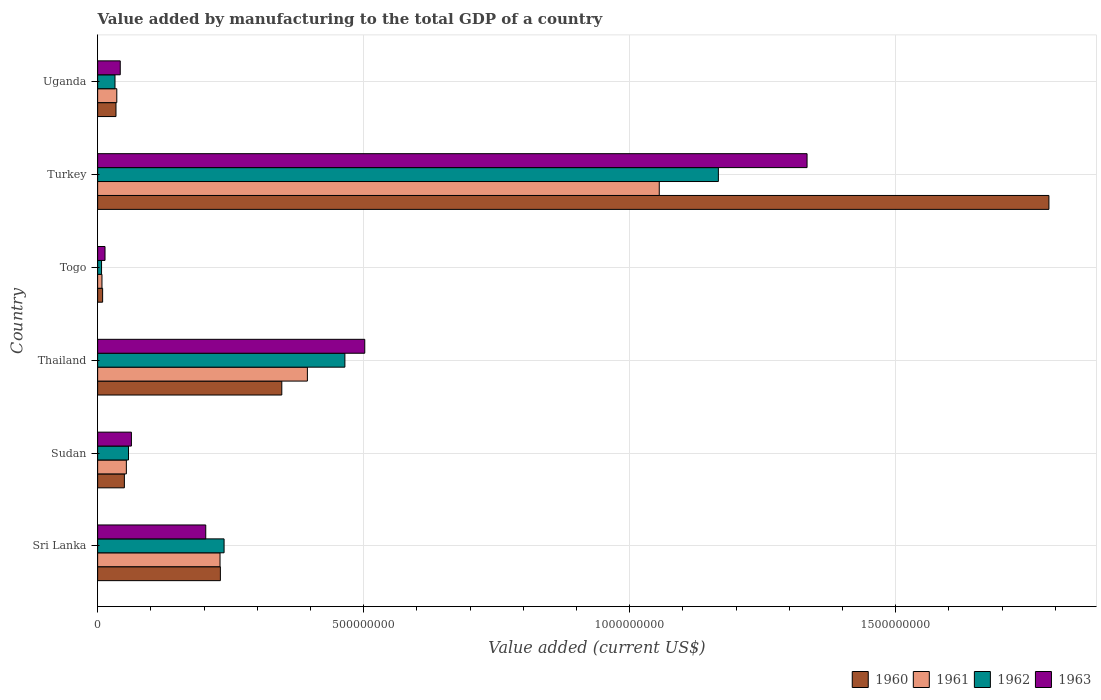How many groups of bars are there?
Provide a short and direct response. 6. Are the number of bars per tick equal to the number of legend labels?
Make the answer very short. Yes. What is the label of the 6th group of bars from the top?
Your answer should be compact. Sri Lanka. In how many cases, is the number of bars for a given country not equal to the number of legend labels?
Provide a succinct answer. 0. What is the value added by manufacturing to the total GDP in 1962 in Thailand?
Your answer should be very brief. 4.65e+08. Across all countries, what is the maximum value added by manufacturing to the total GDP in 1961?
Your answer should be compact. 1.06e+09. Across all countries, what is the minimum value added by manufacturing to the total GDP in 1962?
Provide a short and direct response. 7.35e+06. In which country was the value added by manufacturing to the total GDP in 1960 maximum?
Offer a terse response. Turkey. In which country was the value added by manufacturing to the total GDP in 1961 minimum?
Offer a terse response. Togo. What is the total value added by manufacturing to the total GDP in 1963 in the graph?
Give a very brief answer. 2.16e+09. What is the difference between the value added by manufacturing to the total GDP in 1960 in Sudan and that in Togo?
Make the answer very short. 4.09e+07. What is the difference between the value added by manufacturing to the total GDP in 1962 in Turkey and the value added by manufacturing to the total GDP in 1961 in Sri Lanka?
Give a very brief answer. 9.37e+08. What is the average value added by manufacturing to the total GDP in 1962 per country?
Your response must be concise. 3.28e+08. What is the difference between the value added by manufacturing to the total GDP in 1960 and value added by manufacturing to the total GDP in 1961 in Turkey?
Provide a succinct answer. 7.32e+08. What is the ratio of the value added by manufacturing to the total GDP in 1962 in Sri Lanka to that in Thailand?
Make the answer very short. 0.51. Is the difference between the value added by manufacturing to the total GDP in 1960 in Sri Lanka and Thailand greater than the difference between the value added by manufacturing to the total GDP in 1961 in Sri Lanka and Thailand?
Offer a terse response. Yes. What is the difference between the highest and the second highest value added by manufacturing to the total GDP in 1961?
Your answer should be compact. 6.61e+08. What is the difference between the highest and the lowest value added by manufacturing to the total GDP in 1963?
Your response must be concise. 1.32e+09. Is it the case that in every country, the sum of the value added by manufacturing to the total GDP in 1962 and value added by manufacturing to the total GDP in 1960 is greater than the sum of value added by manufacturing to the total GDP in 1963 and value added by manufacturing to the total GDP in 1961?
Make the answer very short. No. What does the 3rd bar from the top in Thailand represents?
Offer a terse response. 1961. What does the 2nd bar from the bottom in Sudan represents?
Your answer should be very brief. 1961. How many bars are there?
Your response must be concise. 24. What is the difference between two consecutive major ticks on the X-axis?
Provide a succinct answer. 5.00e+08. Does the graph contain any zero values?
Keep it short and to the point. No. Does the graph contain grids?
Keep it short and to the point. Yes. How are the legend labels stacked?
Ensure brevity in your answer.  Horizontal. What is the title of the graph?
Give a very brief answer. Value added by manufacturing to the total GDP of a country. Does "1995" appear as one of the legend labels in the graph?
Make the answer very short. No. What is the label or title of the X-axis?
Give a very brief answer. Value added (current US$). What is the Value added (current US$) in 1960 in Sri Lanka?
Keep it short and to the point. 2.31e+08. What is the Value added (current US$) of 1961 in Sri Lanka?
Keep it short and to the point. 2.30e+08. What is the Value added (current US$) in 1962 in Sri Lanka?
Provide a succinct answer. 2.38e+08. What is the Value added (current US$) in 1963 in Sri Lanka?
Give a very brief answer. 2.03e+08. What is the Value added (current US$) of 1960 in Sudan?
Keep it short and to the point. 5.03e+07. What is the Value added (current US$) in 1961 in Sudan?
Make the answer very short. 5.40e+07. What is the Value added (current US$) in 1962 in Sudan?
Your response must be concise. 5.80e+07. What is the Value added (current US$) of 1963 in Sudan?
Your answer should be compact. 6.35e+07. What is the Value added (current US$) of 1960 in Thailand?
Offer a terse response. 3.46e+08. What is the Value added (current US$) of 1961 in Thailand?
Offer a very short reply. 3.94e+08. What is the Value added (current US$) in 1962 in Thailand?
Your answer should be compact. 4.65e+08. What is the Value added (current US$) of 1963 in Thailand?
Your response must be concise. 5.02e+08. What is the Value added (current US$) of 1960 in Togo?
Your answer should be compact. 9.38e+06. What is the Value added (current US$) in 1961 in Togo?
Your answer should be very brief. 8.15e+06. What is the Value added (current US$) in 1962 in Togo?
Your response must be concise. 7.35e+06. What is the Value added (current US$) in 1963 in Togo?
Make the answer very short. 1.39e+07. What is the Value added (current US$) in 1960 in Turkey?
Provide a short and direct response. 1.79e+09. What is the Value added (current US$) of 1961 in Turkey?
Your answer should be very brief. 1.06e+09. What is the Value added (current US$) in 1962 in Turkey?
Your response must be concise. 1.17e+09. What is the Value added (current US$) of 1963 in Turkey?
Offer a terse response. 1.33e+09. What is the Value added (current US$) in 1960 in Uganda?
Make the answer very short. 3.45e+07. What is the Value added (current US$) in 1961 in Uganda?
Provide a succinct answer. 3.60e+07. What is the Value added (current US$) of 1962 in Uganda?
Ensure brevity in your answer.  3.26e+07. What is the Value added (current US$) of 1963 in Uganda?
Your answer should be very brief. 4.25e+07. Across all countries, what is the maximum Value added (current US$) in 1960?
Offer a very short reply. 1.79e+09. Across all countries, what is the maximum Value added (current US$) of 1961?
Provide a short and direct response. 1.06e+09. Across all countries, what is the maximum Value added (current US$) in 1962?
Your response must be concise. 1.17e+09. Across all countries, what is the maximum Value added (current US$) in 1963?
Give a very brief answer. 1.33e+09. Across all countries, what is the minimum Value added (current US$) in 1960?
Give a very brief answer. 9.38e+06. Across all countries, what is the minimum Value added (current US$) in 1961?
Provide a succinct answer. 8.15e+06. Across all countries, what is the minimum Value added (current US$) in 1962?
Your response must be concise. 7.35e+06. Across all countries, what is the minimum Value added (current US$) of 1963?
Ensure brevity in your answer.  1.39e+07. What is the total Value added (current US$) of 1960 in the graph?
Your answer should be compact. 2.46e+09. What is the total Value added (current US$) of 1961 in the graph?
Offer a very short reply. 1.78e+09. What is the total Value added (current US$) in 1962 in the graph?
Keep it short and to the point. 1.97e+09. What is the total Value added (current US$) of 1963 in the graph?
Keep it short and to the point. 2.16e+09. What is the difference between the Value added (current US$) in 1960 in Sri Lanka and that in Sudan?
Your answer should be very brief. 1.80e+08. What is the difference between the Value added (current US$) of 1961 in Sri Lanka and that in Sudan?
Your answer should be very brief. 1.76e+08. What is the difference between the Value added (current US$) in 1962 in Sri Lanka and that in Sudan?
Offer a terse response. 1.80e+08. What is the difference between the Value added (current US$) in 1963 in Sri Lanka and that in Sudan?
Your answer should be very brief. 1.40e+08. What is the difference between the Value added (current US$) of 1960 in Sri Lanka and that in Thailand?
Make the answer very short. -1.15e+08. What is the difference between the Value added (current US$) in 1961 in Sri Lanka and that in Thailand?
Give a very brief answer. -1.64e+08. What is the difference between the Value added (current US$) of 1962 in Sri Lanka and that in Thailand?
Offer a very short reply. -2.27e+08. What is the difference between the Value added (current US$) of 1963 in Sri Lanka and that in Thailand?
Your answer should be very brief. -2.99e+08. What is the difference between the Value added (current US$) of 1960 in Sri Lanka and that in Togo?
Provide a short and direct response. 2.21e+08. What is the difference between the Value added (current US$) of 1961 in Sri Lanka and that in Togo?
Give a very brief answer. 2.22e+08. What is the difference between the Value added (current US$) in 1962 in Sri Lanka and that in Togo?
Keep it short and to the point. 2.30e+08. What is the difference between the Value added (current US$) in 1963 in Sri Lanka and that in Togo?
Provide a succinct answer. 1.89e+08. What is the difference between the Value added (current US$) in 1960 in Sri Lanka and that in Turkey?
Your answer should be compact. -1.56e+09. What is the difference between the Value added (current US$) in 1961 in Sri Lanka and that in Turkey?
Provide a succinct answer. -8.26e+08. What is the difference between the Value added (current US$) of 1962 in Sri Lanka and that in Turkey?
Offer a very short reply. -9.29e+08. What is the difference between the Value added (current US$) in 1963 in Sri Lanka and that in Turkey?
Provide a short and direct response. -1.13e+09. What is the difference between the Value added (current US$) of 1960 in Sri Lanka and that in Uganda?
Keep it short and to the point. 1.96e+08. What is the difference between the Value added (current US$) in 1961 in Sri Lanka and that in Uganda?
Provide a short and direct response. 1.94e+08. What is the difference between the Value added (current US$) in 1962 in Sri Lanka and that in Uganda?
Give a very brief answer. 2.05e+08. What is the difference between the Value added (current US$) in 1963 in Sri Lanka and that in Uganda?
Offer a terse response. 1.61e+08. What is the difference between the Value added (current US$) in 1960 in Sudan and that in Thailand?
Your answer should be very brief. -2.96e+08. What is the difference between the Value added (current US$) in 1961 in Sudan and that in Thailand?
Ensure brevity in your answer.  -3.40e+08. What is the difference between the Value added (current US$) of 1962 in Sudan and that in Thailand?
Offer a very short reply. -4.07e+08. What is the difference between the Value added (current US$) in 1963 in Sudan and that in Thailand?
Give a very brief answer. -4.39e+08. What is the difference between the Value added (current US$) in 1960 in Sudan and that in Togo?
Offer a very short reply. 4.09e+07. What is the difference between the Value added (current US$) of 1961 in Sudan and that in Togo?
Provide a short and direct response. 4.58e+07. What is the difference between the Value added (current US$) in 1962 in Sudan and that in Togo?
Ensure brevity in your answer.  5.07e+07. What is the difference between the Value added (current US$) in 1963 in Sudan and that in Togo?
Provide a short and direct response. 4.96e+07. What is the difference between the Value added (current US$) in 1960 in Sudan and that in Turkey?
Give a very brief answer. -1.74e+09. What is the difference between the Value added (current US$) in 1961 in Sudan and that in Turkey?
Your answer should be very brief. -1.00e+09. What is the difference between the Value added (current US$) of 1962 in Sudan and that in Turkey?
Give a very brief answer. -1.11e+09. What is the difference between the Value added (current US$) of 1963 in Sudan and that in Turkey?
Your answer should be compact. -1.27e+09. What is the difference between the Value added (current US$) of 1960 in Sudan and that in Uganda?
Give a very brief answer. 1.58e+07. What is the difference between the Value added (current US$) of 1961 in Sudan and that in Uganda?
Offer a terse response. 1.80e+07. What is the difference between the Value added (current US$) of 1962 in Sudan and that in Uganda?
Ensure brevity in your answer.  2.54e+07. What is the difference between the Value added (current US$) in 1963 in Sudan and that in Uganda?
Offer a terse response. 2.10e+07. What is the difference between the Value added (current US$) of 1960 in Thailand and that in Togo?
Keep it short and to the point. 3.37e+08. What is the difference between the Value added (current US$) of 1961 in Thailand and that in Togo?
Keep it short and to the point. 3.86e+08. What is the difference between the Value added (current US$) in 1962 in Thailand and that in Togo?
Make the answer very short. 4.57e+08. What is the difference between the Value added (current US$) in 1963 in Thailand and that in Togo?
Ensure brevity in your answer.  4.88e+08. What is the difference between the Value added (current US$) of 1960 in Thailand and that in Turkey?
Your answer should be compact. -1.44e+09. What is the difference between the Value added (current US$) in 1961 in Thailand and that in Turkey?
Your response must be concise. -6.61e+08. What is the difference between the Value added (current US$) of 1962 in Thailand and that in Turkey?
Your answer should be very brief. -7.02e+08. What is the difference between the Value added (current US$) in 1963 in Thailand and that in Turkey?
Offer a very short reply. -8.31e+08. What is the difference between the Value added (current US$) of 1960 in Thailand and that in Uganda?
Provide a succinct answer. 3.12e+08. What is the difference between the Value added (current US$) in 1961 in Thailand and that in Uganda?
Your response must be concise. 3.58e+08. What is the difference between the Value added (current US$) in 1962 in Thailand and that in Uganda?
Keep it short and to the point. 4.32e+08. What is the difference between the Value added (current US$) of 1963 in Thailand and that in Uganda?
Your answer should be compact. 4.60e+08. What is the difference between the Value added (current US$) of 1960 in Togo and that in Turkey?
Provide a succinct answer. -1.78e+09. What is the difference between the Value added (current US$) of 1961 in Togo and that in Turkey?
Make the answer very short. -1.05e+09. What is the difference between the Value added (current US$) of 1962 in Togo and that in Turkey?
Offer a very short reply. -1.16e+09. What is the difference between the Value added (current US$) of 1963 in Togo and that in Turkey?
Give a very brief answer. -1.32e+09. What is the difference between the Value added (current US$) in 1960 in Togo and that in Uganda?
Your response must be concise. -2.51e+07. What is the difference between the Value added (current US$) in 1961 in Togo and that in Uganda?
Your response must be concise. -2.79e+07. What is the difference between the Value added (current US$) of 1962 in Togo and that in Uganda?
Offer a very short reply. -2.53e+07. What is the difference between the Value added (current US$) in 1963 in Togo and that in Uganda?
Your response must be concise. -2.86e+07. What is the difference between the Value added (current US$) in 1960 in Turkey and that in Uganda?
Your answer should be very brief. 1.75e+09. What is the difference between the Value added (current US$) of 1961 in Turkey and that in Uganda?
Your answer should be compact. 1.02e+09. What is the difference between the Value added (current US$) of 1962 in Turkey and that in Uganda?
Your response must be concise. 1.13e+09. What is the difference between the Value added (current US$) of 1963 in Turkey and that in Uganda?
Your answer should be compact. 1.29e+09. What is the difference between the Value added (current US$) of 1960 in Sri Lanka and the Value added (current US$) of 1961 in Sudan?
Your answer should be compact. 1.77e+08. What is the difference between the Value added (current US$) of 1960 in Sri Lanka and the Value added (current US$) of 1962 in Sudan?
Keep it short and to the point. 1.73e+08. What is the difference between the Value added (current US$) of 1960 in Sri Lanka and the Value added (current US$) of 1963 in Sudan?
Your answer should be very brief. 1.67e+08. What is the difference between the Value added (current US$) of 1961 in Sri Lanka and the Value added (current US$) of 1962 in Sudan?
Your answer should be compact. 1.72e+08. What is the difference between the Value added (current US$) in 1961 in Sri Lanka and the Value added (current US$) in 1963 in Sudan?
Keep it short and to the point. 1.67e+08. What is the difference between the Value added (current US$) of 1962 in Sri Lanka and the Value added (current US$) of 1963 in Sudan?
Provide a short and direct response. 1.74e+08. What is the difference between the Value added (current US$) in 1960 in Sri Lanka and the Value added (current US$) in 1961 in Thailand?
Offer a terse response. -1.64e+08. What is the difference between the Value added (current US$) of 1960 in Sri Lanka and the Value added (current US$) of 1962 in Thailand?
Your response must be concise. -2.34e+08. What is the difference between the Value added (current US$) in 1960 in Sri Lanka and the Value added (current US$) in 1963 in Thailand?
Provide a succinct answer. -2.71e+08. What is the difference between the Value added (current US$) in 1961 in Sri Lanka and the Value added (current US$) in 1962 in Thailand?
Provide a succinct answer. -2.35e+08. What is the difference between the Value added (current US$) in 1961 in Sri Lanka and the Value added (current US$) in 1963 in Thailand?
Give a very brief answer. -2.72e+08. What is the difference between the Value added (current US$) in 1962 in Sri Lanka and the Value added (current US$) in 1963 in Thailand?
Offer a terse response. -2.64e+08. What is the difference between the Value added (current US$) in 1960 in Sri Lanka and the Value added (current US$) in 1961 in Togo?
Ensure brevity in your answer.  2.23e+08. What is the difference between the Value added (current US$) of 1960 in Sri Lanka and the Value added (current US$) of 1962 in Togo?
Provide a succinct answer. 2.23e+08. What is the difference between the Value added (current US$) in 1960 in Sri Lanka and the Value added (current US$) in 1963 in Togo?
Provide a short and direct response. 2.17e+08. What is the difference between the Value added (current US$) of 1961 in Sri Lanka and the Value added (current US$) of 1962 in Togo?
Provide a short and direct response. 2.23e+08. What is the difference between the Value added (current US$) of 1961 in Sri Lanka and the Value added (current US$) of 1963 in Togo?
Your answer should be compact. 2.16e+08. What is the difference between the Value added (current US$) in 1962 in Sri Lanka and the Value added (current US$) in 1963 in Togo?
Your answer should be very brief. 2.24e+08. What is the difference between the Value added (current US$) in 1960 in Sri Lanka and the Value added (current US$) in 1961 in Turkey?
Give a very brief answer. -8.25e+08. What is the difference between the Value added (current US$) in 1960 in Sri Lanka and the Value added (current US$) in 1962 in Turkey?
Your response must be concise. -9.36e+08. What is the difference between the Value added (current US$) in 1960 in Sri Lanka and the Value added (current US$) in 1963 in Turkey?
Your answer should be compact. -1.10e+09. What is the difference between the Value added (current US$) of 1961 in Sri Lanka and the Value added (current US$) of 1962 in Turkey?
Provide a short and direct response. -9.37e+08. What is the difference between the Value added (current US$) in 1961 in Sri Lanka and the Value added (current US$) in 1963 in Turkey?
Give a very brief answer. -1.10e+09. What is the difference between the Value added (current US$) of 1962 in Sri Lanka and the Value added (current US$) of 1963 in Turkey?
Keep it short and to the point. -1.10e+09. What is the difference between the Value added (current US$) in 1960 in Sri Lanka and the Value added (current US$) in 1961 in Uganda?
Give a very brief answer. 1.95e+08. What is the difference between the Value added (current US$) of 1960 in Sri Lanka and the Value added (current US$) of 1962 in Uganda?
Provide a succinct answer. 1.98e+08. What is the difference between the Value added (current US$) in 1960 in Sri Lanka and the Value added (current US$) in 1963 in Uganda?
Make the answer very short. 1.88e+08. What is the difference between the Value added (current US$) in 1961 in Sri Lanka and the Value added (current US$) in 1962 in Uganda?
Give a very brief answer. 1.97e+08. What is the difference between the Value added (current US$) in 1961 in Sri Lanka and the Value added (current US$) in 1963 in Uganda?
Give a very brief answer. 1.88e+08. What is the difference between the Value added (current US$) in 1962 in Sri Lanka and the Value added (current US$) in 1963 in Uganda?
Give a very brief answer. 1.95e+08. What is the difference between the Value added (current US$) of 1960 in Sudan and the Value added (current US$) of 1961 in Thailand?
Ensure brevity in your answer.  -3.44e+08. What is the difference between the Value added (current US$) of 1960 in Sudan and the Value added (current US$) of 1962 in Thailand?
Keep it short and to the point. -4.14e+08. What is the difference between the Value added (current US$) of 1960 in Sudan and the Value added (current US$) of 1963 in Thailand?
Offer a terse response. -4.52e+08. What is the difference between the Value added (current US$) of 1961 in Sudan and the Value added (current US$) of 1962 in Thailand?
Keep it short and to the point. -4.11e+08. What is the difference between the Value added (current US$) in 1961 in Sudan and the Value added (current US$) in 1963 in Thailand?
Your answer should be compact. -4.48e+08. What is the difference between the Value added (current US$) in 1962 in Sudan and the Value added (current US$) in 1963 in Thailand?
Offer a terse response. -4.44e+08. What is the difference between the Value added (current US$) of 1960 in Sudan and the Value added (current US$) of 1961 in Togo?
Your answer should be very brief. 4.21e+07. What is the difference between the Value added (current US$) in 1960 in Sudan and the Value added (current US$) in 1962 in Togo?
Your response must be concise. 4.29e+07. What is the difference between the Value added (current US$) of 1960 in Sudan and the Value added (current US$) of 1963 in Togo?
Your response must be concise. 3.64e+07. What is the difference between the Value added (current US$) of 1961 in Sudan and the Value added (current US$) of 1962 in Togo?
Ensure brevity in your answer.  4.66e+07. What is the difference between the Value added (current US$) of 1961 in Sudan and the Value added (current US$) of 1963 in Togo?
Ensure brevity in your answer.  4.01e+07. What is the difference between the Value added (current US$) of 1962 in Sudan and the Value added (current US$) of 1963 in Togo?
Provide a succinct answer. 4.41e+07. What is the difference between the Value added (current US$) of 1960 in Sudan and the Value added (current US$) of 1961 in Turkey?
Your response must be concise. -1.01e+09. What is the difference between the Value added (current US$) of 1960 in Sudan and the Value added (current US$) of 1962 in Turkey?
Make the answer very short. -1.12e+09. What is the difference between the Value added (current US$) of 1960 in Sudan and the Value added (current US$) of 1963 in Turkey?
Offer a very short reply. -1.28e+09. What is the difference between the Value added (current US$) of 1961 in Sudan and the Value added (current US$) of 1962 in Turkey?
Your answer should be very brief. -1.11e+09. What is the difference between the Value added (current US$) in 1961 in Sudan and the Value added (current US$) in 1963 in Turkey?
Provide a succinct answer. -1.28e+09. What is the difference between the Value added (current US$) in 1962 in Sudan and the Value added (current US$) in 1963 in Turkey?
Provide a succinct answer. -1.28e+09. What is the difference between the Value added (current US$) of 1960 in Sudan and the Value added (current US$) of 1961 in Uganda?
Your answer should be compact. 1.42e+07. What is the difference between the Value added (current US$) of 1960 in Sudan and the Value added (current US$) of 1962 in Uganda?
Make the answer very short. 1.76e+07. What is the difference between the Value added (current US$) of 1960 in Sudan and the Value added (current US$) of 1963 in Uganda?
Give a very brief answer. 7.75e+06. What is the difference between the Value added (current US$) of 1961 in Sudan and the Value added (current US$) of 1962 in Uganda?
Provide a succinct answer. 2.14e+07. What is the difference between the Value added (current US$) of 1961 in Sudan and the Value added (current US$) of 1963 in Uganda?
Offer a terse response. 1.15e+07. What is the difference between the Value added (current US$) in 1962 in Sudan and the Value added (current US$) in 1963 in Uganda?
Your answer should be very brief. 1.55e+07. What is the difference between the Value added (current US$) in 1960 in Thailand and the Value added (current US$) in 1961 in Togo?
Ensure brevity in your answer.  3.38e+08. What is the difference between the Value added (current US$) in 1960 in Thailand and the Value added (current US$) in 1962 in Togo?
Make the answer very short. 3.39e+08. What is the difference between the Value added (current US$) in 1960 in Thailand and the Value added (current US$) in 1963 in Togo?
Your response must be concise. 3.32e+08. What is the difference between the Value added (current US$) of 1961 in Thailand and the Value added (current US$) of 1962 in Togo?
Ensure brevity in your answer.  3.87e+08. What is the difference between the Value added (current US$) of 1961 in Thailand and the Value added (current US$) of 1963 in Togo?
Your answer should be compact. 3.80e+08. What is the difference between the Value added (current US$) in 1962 in Thailand and the Value added (current US$) in 1963 in Togo?
Provide a succinct answer. 4.51e+08. What is the difference between the Value added (current US$) of 1960 in Thailand and the Value added (current US$) of 1961 in Turkey?
Your response must be concise. -7.09e+08. What is the difference between the Value added (current US$) of 1960 in Thailand and the Value added (current US$) of 1962 in Turkey?
Provide a succinct answer. -8.21e+08. What is the difference between the Value added (current US$) in 1960 in Thailand and the Value added (current US$) in 1963 in Turkey?
Make the answer very short. -9.87e+08. What is the difference between the Value added (current US$) in 1961 in Thailand and the Value added (current US$) in 1962 in Turkey?
Ensure brevity in your answer.  -7.72e+08. What is the difference between the Value added (current US$) in 1961 in Thailand and the Value added (current US$) in 1963 in Turkey?
Ensure brevity in your answer.  -9.39e+08. What is the difference between the Value added (current US$) of 1962 in Thailand and the Value added (current US$) of 1963 in Turkey?
Offer a very short reply. -8.69e+08. What is the difference between the Value added (current US$) of 1960 in Thailand and the Value added (current US$) of 1961 in Uganda?
Offer a very short reply. 3.10e+08. What is the difference between the Value added (current US$) of 1960 in Thailand and the Value added (current US$) of 1962 in Uganda?
Make the answer very short. 3.13e+08. What is the difference between the Value added (current US$) of 1960 in Thailand and the Value added (current US$) of 1963 in Uganda?
Offer a terse response. 3.04e+08. What is the difference between the Value added (current US$) in 1961 in Thailand and the Value added (current US$) in 1962 in Uganda?
Ensure brevity in your answer.  3.62e+08. What is the difference between the Value added (current US$) of 1961 in Thailand and the Value added (current US$) of 1963 in Uganda?
Provide a short and direct response. 3.52e+08. What is the difference between the Value added (current US$) of 1962 in Thailand and the Value added (current US$) of 1963 in Uganda?
Provide a short and direct response. 4.22e+08. What is the difference between the Value added (current US$) of 1960 in Togo and the Value added (current US$) of 1961 in Turkey?
Offer a very short reply. -1.05e+09. What is the difference between the Value added (current US$) of 1960 in Togo and the Value added (current US$) of 1962 in Turkey?
Offer a terse response. -1.16e+09. What is the difference between the Value added (current US$) in 1960 in Togo and the Value added (current US$) in 1963 in Turkey?
Keep it short and to the point. -1.32e+09. What is the difference between the Value added (current US$) of 1961 in Togo and the Value added (current US$) of 1962 in Turkey?
Your answer should be very brief. -1.16e+09. What is the difference between the Value added (current US$) of 1961 in Togo and the Value added (current US$) of 1963 in Turkey?
Offer a very short reply. -1.33e+09. What is the difference between the Value added (current US$) of 1962 in Togo and the Value added (current US$) of 1963 in Turkey?
Provide a short and direct response. -1.33e+09. What is the difference between the Value added (current US$) of 1960 in Togo and the Value added (current US$) of 1961 in Uganda?
Provide a succinct answer. -2.66e+07. What is the difference between the Value added (current US$) of 1960 in Togo and the Value added (current US$) of 1962 in Uganda?
Your answer should be very brief. -2.33e+07. What is the difference between the Value added (current US$) in 1960 in Togo and the Value added (current US$) in 1963 in Uganda?
Keep it short and to the point. -3.31e+07. What is the difference between the Value added (current US$) in 1961 in Togo and the Value added (current US$) in 1962 in Uganda?
Offer a very short reply. -2.45e+07. What is the difference between the Value added (current US$) of 1961 in Togo and the Value added (current US$) of 1963 in Uganda?
Your response must be concise. -3.44e+07. What is the difference between the Value added (current US$) of 1962 in Togo and the Value added (current US$) of 1963 in Uganda?
Make the answer very short. -3.52e+07. What is the difference between the Value added (current US$) of 1960 in Turkey and the Value added (current US$) of 1961 in Uganda?
Keep it short and to the point. 1.75e+09. What is the difference between the Value added (current US$) of 1960 in Turkey and the Value added (current US$) of 1962 in Uganda?
Provide a succinct answer. 1.76e+09. What is the difference between the Value added (current US$) in 1960 in Turkey and the Value added (current US$) in 1963 in Uganda?
Give a very brief answer. 1.75e+09. What is the difference between the Value added (current US$) of 1961 in Turkey and the Value added (current US$) of 1962 in Uganda?
Offer a very short reply. 1.02e+09. What is the difference between the Value added (current US$) of 1961 in Turkey and the Value added (current US$) of 1963 in Uganda?
Ensure brevity in your answer.  1.01e+09. What is the difference between the Value added (current US$) in 1962 in Turkey and the Value added (current US$) in 1963 in Uganda?
Ensure brevity in your answer.  1.12e+09. What is the average Value added (current US$) in 1960 per country?
Provide a succinct answer. 4.10e+08. What is the average Value added (current US$) in 1961 per country?
Your response must be concise. 2.96e+08. What is the average Value added (current US$) in 1962 per country?
Provide a short and direct response. 3.28e+08. What is the average Value added (current US$) in 1963 per country?
Keep it short and to the point. 3.60e+08. What is the difference between the Value added (current US$) of 1960 and Value added (current US$) of 1961 in Sri Lanka?
Give a very brief answer. 6.30e+05. What is the difference between the Value added (current US$) in 1960 and Value added (current US$) in 1962 in Sri Lanka?
Give a very brief answer. -6.98e+06. What is the difference between the Value added (current US$) in 1960 and Value added (current US$) in 1963 in Sri Lanka?
Keep it short and to the point. 2.75e+07. What is the difference between the Value added (current US$) of 1961 and Value added (current US$) of 1962 in Sri Lanka?
Give a very brief answer. -7.61e+06. What is the difference between the Value added (current US$) in 1961 and Value added (current US$) in 1963 in Sri Lanka?
Your answer should be very brief. 2.68e+07. What is the difference between the Value added (current US$) in 1962 and Value added (current US$) in 1963 in Sri Lanka?
Your answer should be very brief. 3.45e+07. What is the difference between the Value added (current US$) in 1960 and Value added (current US$) in 1961 in Sudan?
Give a very brief answer. -3.73e+06. What is the difference between the Value added (current US$) of 1960 and Value added (current US$) of 1962 in Sudan?
Offer a terse response. -7.75e+06. What is the difference between the Value added (current US$) of 1960 and Value added (current US$) of 1963 in Sudan?
Give a very brief answer. -1.32e+07. What is the difference between the Value added (current US$) of 1961 and Value added (current US$) of 1962 in Sudan?
Make the answer very short. -4.02e+06. What is the difference between the Value added (current US$) of 1961 and Value added (current US$) of 1963 in Sudan?
Your response must be concise. -9.48e+06. What is the difference between the Value added (current US$) of 1962 and Value added (current US$) of 1963 in Sudan?
Offer a very short reply. -5.46e+06. What is the difference between the Value added (current US$) of 1960 and Value added (current US$) of 1961 in Thailand?
Your answer should be very brief. -4.81e+07. What is the difference between the Value added (current US$) of 1960 and Value added (current US$) of 1962 in Thailand?
Give a very brief answer. -1.19e+08. What is the difference between the Value added (current US$) in 1960 and Value added (current US$) in 1963 in Thailand?
Provide a succinct answer. -1.56e+08. What is the difference between the Value added (current US$) of 1961 and Value added (current US$) of 1962 in Thailand?
Keep it short and to the point. -7.05e+07. What is the difference between the Value added (current US$) of 1961 and Value added (current US$) of 1963 in Thailand?
Ensure brevity in your answer.  -1.08e+08. What is the difference between the Value added (current US$) in 1962 and Value added (current US$) in 1963 in Thailand?
Your answer should be very brief. -3.73e+07. What is the difference between the Value added (current US$) of 1960 and Value added (current US$) of 1961 in Togo?
Give a very brief answer. 1.23e+06. What is the difference between the Value added (current US$) of 1960 and Value added (current US$) of 1962 in Togo?
Offer a very short reply. 2.03e+06. What is the difference between the Value added (current US$) of 1960 and Value added (current US$) of 1963 in Togo?
Provide a short and direct response. -4.50e+06. What is the difference between the Value added (current US$) in 1961 and Value added (current US$) in 1962 in Togo?
Your answer should be compact. 8.08e+05. What is the difference between the Value added (current US$) in 1961 and Value added (current US$) in 1963 in Togo?
Keep it short and to the point. -5.72e+06. What is the difference between the Value added (current US$) of 1962 and Value added (current US$) of 1963 in Togo?
Provide a short and direct response. -6.53e+06. What is the difference between the Value added (current US$) of 1960 and Value added (current US$) of 1961 in Turkey?
Provide a succinct answer. 7.32e+08. What is the difference between the Value added (current US$) of 1960 and Value added (current US$) of 1962 in Turkey?
Your answer should be very brief. 6.21e+08. What is the difference between the Value added (current US$) in 1960 and Value added (current US$) in 1963 in Turkey?
Your answer should be very brief. 4.55e+08. What is the difference between the Value added (current US$) in 1961 and Value added (current US$) in 1962 in Turkey?
Your response must be concise. -1.11e+08. What is the difference between the Value added (current US$) of 1961 and Value added (current US$) of 1963 in Turkey?
Your answer should be very brief. -2.78e+08. What is the difference between the Value added (current US$) of 1962 and Value added (current US$) of 1963 in Turkey?
Your response must be concise. -1.67e+08. What is the difference between the Value added (current US$) in 1960 and Value added (current US$) in 1961 in Uganda?
Give a very brief answer. -1.54e+06. What is the difference between the Value added (current US$) in 1960 and Value added (current US$) in 1962 in Uganda?
Your answer should be very brief. 1.85e+06. What is the difference between the Value added (current US$) of 1960 and Value added (current US$) of 1963 in Uganda?
Ensure brevity in your answer.  -8.03e+06. What is the difference between the Value added (current US$) in 1961 and Value added (current US$) in 1962 in Uganda?
Offer a terse response. 3.39e+06. What is the difference between the Value added (current US$) in 1961 and Value added (current US$) in 1963 in Uganda?
Your response must be concise. -6.48e+06. What is the difference between the Value added (current US$) of 1962 and Value added (current US$) of 1963 in Uganda?
Provide a short and direct response. -9.87e+06. What is the ratio of the Value added (current US$) in 1960 in Sri Lanka to that in Sudan?
Offer a very short reply. 4.59. What is the ratio of the Value added (current US$) of 1961 in Sri Lanka to that in Sudan?
Your answer should be compact. 4.26. What is the ratio of the Value added (current US$) in 1962 in Sri Lanka to that in Sudan?
Provide a short and direct response. 4.1. What is the ratio of the Value added (current US$) in 1963 in Sri Lanka to that in Sudan?
Provide a succinct answer. 3.2. What is the ratio of the Value added (current US$) in 1960 in Sri Lanka to that in Thailand?
Keep it short and to the point. 0.67. What is the ratio of the Value added (current US$) of 1961 in Sri Lanka to that in Thailand?
Make the answer very short. 0.58. What is the ratio of the Value added (current US$) of 1962 in Sri Lanka to that in Thailand?
Give a very brief answer. 0.51. What is the ratio of the Value added (current US$) of 1963 in Sri Lanka to that in Thailand?
Ensure brevity in your answer.  0.4. What is the ratio of the Value added (current US$) in 1960 in Sri Lanka to that in Togo?
Offer a very short reply. 24.59. What is the ratio of the Value added (current US$) of 1961 in Sri Lanka to that in Togo?
Provide a short and direct response. 28.21. What is the ratio of the Value added (current US$) of 1962 in Sri Lanka to that in Togo?
Ensure brevity in your answer.  32.35. What is the ratio of the Value added (current US$) of 1963 in Sri Lanka to that in Togo?
Give a very brief answer. 14.64. What is the ratio of the Value added (current US$) of 1960 in Sri Lanka to that in Turkey?
Provide a short and direct response. 0.13. What is the ratio of the Value added (current US$) of 1961 in Sri Lanka to that in Turkey?
Give a very brief answer. 0.22. What is the ratio of the Value added (current US$) of 1962 in Sri Lanka to that in Turkey?
Your answer should be very brief. 0.2. What is the ratio of the Value added (current US$) of 1963 in Sri Lanka to that in Turkey?
Provide a short and direct response. 0.15. What is the ratio of the Value added (current US$) in 1960 in Sri Lanka to that in Uganda?
Your answer should be very brief. 6.69. What is the ratio of the Value added (current US$) in 1961 in Sri Lanka to that in Uganda?
Your answer should be compact. 6.39. What is the ratio of the Value added (current US$) in 1962 in Sri Lanka to that in Uganda?
Your answer should be very brief. 7.28. What is the ratio of the Value added (current US$) of 1963 in Sri Lanka to that in Uganda?
Ensure brevity in your answer.  4.78. What is the ratio of the Value added (current US$) of 1960 in Sudan to that in Thailand?
Your response must be concise. 0.15. What is the ratio of the Value added (current US$) in 1961 in Sudan to that in Thailand?
Provide a short and direct response. 0.14. What is the ratio of the Value added (current US$) of 1962 in Sudan to that in Thailand?
Provide a short and direct response. 0.12. What is the ratio of the Value added (current US$) of 1963 in Sudan to that in Thailand?
Offer a terse response. 0.13. What is the ratio of the Value added (current US$) of 1960 in Sudan to that in Togo?
Your answer should be very brief. 5.36. What is the ratio of the Value added (current US$) in 1961 in Sudan to that in Togo?
Your response must be concise. 6.62. What is the ratio of the Value added (current US$) in 1962 in Sudan to that in Togo?
Make the answer very short. 7.9. What is the ratio of the Value added (current US$) in 1963 in Sudan to that in Togo?
Keep it short and to the point. 4.57. What is the ratio of the Value added (current US$) in 1960 in Sudan to that in Turkey?
Provide a succinct answer. 0.03. What is the ratio of the Value added (current US$) in 1961 in Sudan to that in Turkey?
Your answer should be compact. 0.05. What is the ratio of the Value added (current US$) in 1962 in Sudan to that in Turkey?
Ensure brevity in your answer.  0.05. What is the ratio of the Value added (current US$) in 1963 in Sudan to that in Turkey?
Make the answer very short. 0.05. What is the ratio of the Value added (current US$) of 1960 in Sudan to that in Uganda?
Provide a succinct answer. 1.46. What is the ratio of the Value added (current US$) in 1961 in Sudan to that in Uganda?
Offer a terse response. 1.5. What is the ratio of the Value added (current US$) of 1962 in Sudan to that in Uganda?
Offer a terse response. 1.78. What is the ratio of the Value added (current US$) of 1963 in Sudan to that in Uganda?
Your answer should be compact. 1.49. What is the ratio of the Value added (current US$) in 1960 in Thailand to that in Togo?
Provide a succinct answer. 36.9. What is the ratio of the Value added (current US$) of 1961 in Thailand to that in Togo?
Your answer should be compact. 48.34. What is the ratio of the Value added (current US$) in 1962 in Thailand to that in Togo?
Offer a terse response. 63.26. What is the ratio of the Value added (current US$) of 1963 in Thailand to that in Togo?
Keep it short and to the point. 36.18. What is the ratio of the Value added (current US$) in 1960 in Thailand to that in Turkey?
Your response must be concise. 0.19. What is the ratio of the Value added (current US$) of 1961 in Thailand to that in Turkey?
Provide a short and direct response. 0.37. What is the ratio of the Value added (current US$) in 1962 in Thailand to that in Turkey?
Your response must be concise. 0.4. What is the ratio of the Value added (current US$) in 1963 in Thailand to that in Turkey?
Your answer should be very brief. 0.38. What is the ratio of the Value added (current US$) in 1960 in Thailand to that in Uganda?
Ensure brevity in your answer.  10.04. What is the ratio of the Value added (current US$) of 1961 in Thailand to that in Uganda?
Give a very brief answer. 10.94. What is the ratio of the Value added (current US$) in 1962 in Thailand to that in Uganda?
Give a very brief answer. 14.24. What is the ratio of the Value added (current US$) of 1963 in Thailand to that in Uganda?
Offer a terse response. 11.81. What is the ratio of the Value added (current US$) of 1960 in Togo to that in Turkey?
Your response must be concise. 0.01. What is the ratio of the Value added (current US$) in 1961 in Togo to that in Turkey?
Make the answer very short. 0.01. What is the ratio of the Value added (current US$) in 1962 in Togo to that in Turkey?
Keep it short and to the point. 0.01. What is the ratio of the Value added (current US$) of 1963 in Togo to that in Turkey?
Your answer should be very brief. 0.01. What is the ratio of the Value added (current US$) in 1960 in Togo to that in Uganda?
Your answer should be very brief. 0.27. What is the ratio of the Value added (current US$) in 1961 in Togo to that in Uganda?
Provide a succinct answer. 0.23. What is the ratio of the Value added (current US$) in 1962 in Togo to that in Uganda?
Offer a very short reply. 0.23. What is the ratio of the Value added (current US$) of 1963 in Togo to that in Uganda?
Give a very brief answer. 0.33. What is the ratio of the Value added (current US$) in 1960 in Turkey to that in Uganda?
Make the answer very short. 51.86. What is the ratio of the Value added (current US$) in 1961 in Turkey to that in Uganda?
Ensure brevity in your answer.  29.3. What is the ratio of the Value added (current US$) of 1962 in Turkey to that in Uganda?
Your answer should be very brief. 35.75. What is the ratio of the Value added (current US$) in 1963 in Turkey to that in Uganda?
Offer a very short reply. 31.37. What is the difference between the highest and the second highest Value added (current US$) of 1960?
Provide a short and direct response. 1.44e+09. What is the difference between the highest and the second highest Value added (current US$) in 1961?
Your answer should be compact. 6.61e+08. What is the difference between the highest and the second highest Value added (current US$) of 1962?
Offer a terse response. 7.02e+08. What is the difference between the highest and the second highest Value added (current US$) in 1963?
Your response must be concise. 8.31e+08. What is the difference between the highest and the lowest Value added (current US$) in 1960?
Give a very brief answer. 1.78e+09. What is the difference between the highest and the lowest Value added (current US$) in 1961?
Make the answer very short. 1.05e+09. What is the difference between the highest and the lowest Value added (current US$) of 1962?
Offer a very short reply. 1.16e+09. What is the difference between the highest and the lowest Value added (current US$) in 1963?
Offer a terse response. 1.32e+09. 